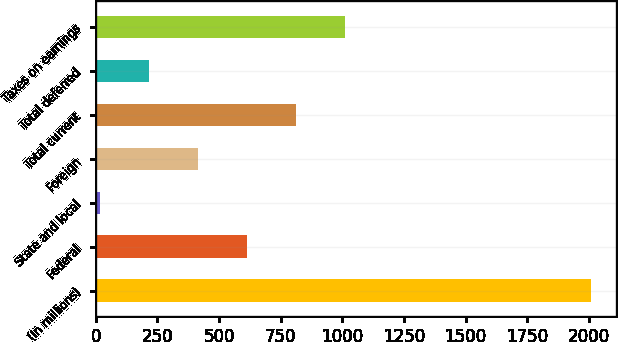<chart> <loc_0><loc_0><loc_500><loc_500><bar_chart><fcel>(In millions)<fcel>Federal<fcel>State and local<fcel>Foreign<fcel>Total current<fcel>Total deferred<fcel>Taxes on earnings<nl><fcel>2010<fcel>613.85<fcel>15.5<fcel>414.4<fcel>813.3<fcel>214.95<fcel>1012.75<nl></chart> 